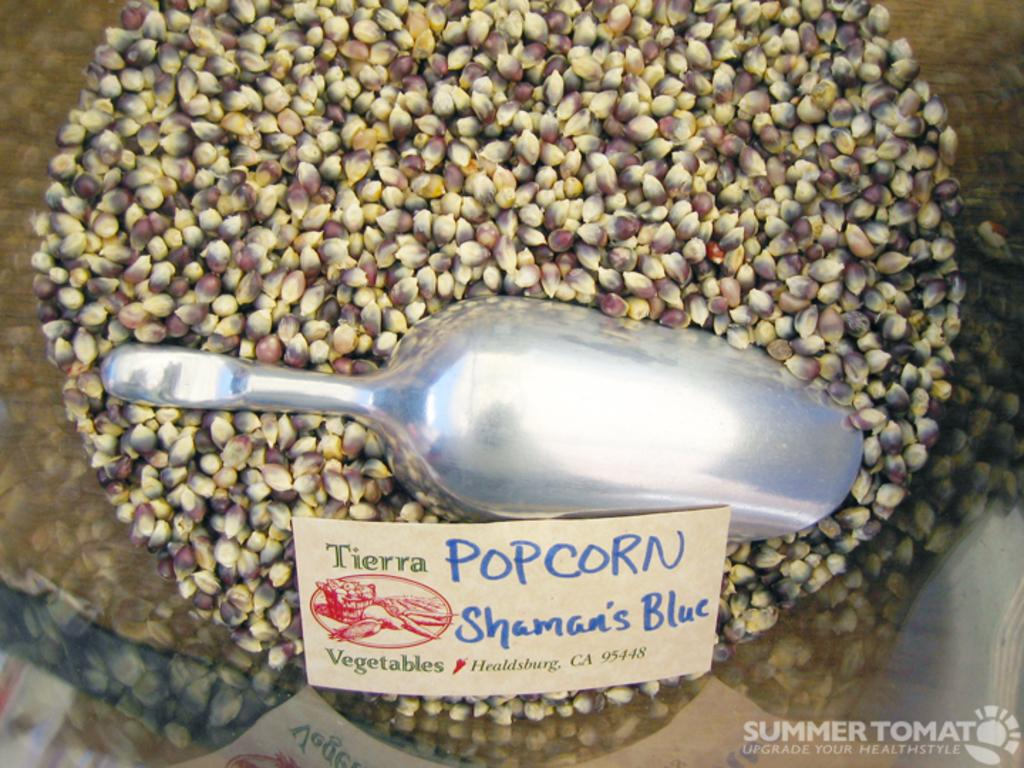What type of food is visible in the image? There are popcorn seeds in the image. What object in the image might be used for labeling or identification? There is a name board with text in the image. What kitchen item can be seen in the image? There is a measuring jug in the image. Can you describe any markings or logos in the image? There is a watermark in the bottom right corner of the image. How many toys are present on the name board in the image? There are no toys visible on the name board in the image. What type of owl can be seen sitting on the measuring jug in the image? There is no owl present in the image; it only features popcorn seeds, a name board, a measuring jug, and a watermark. 